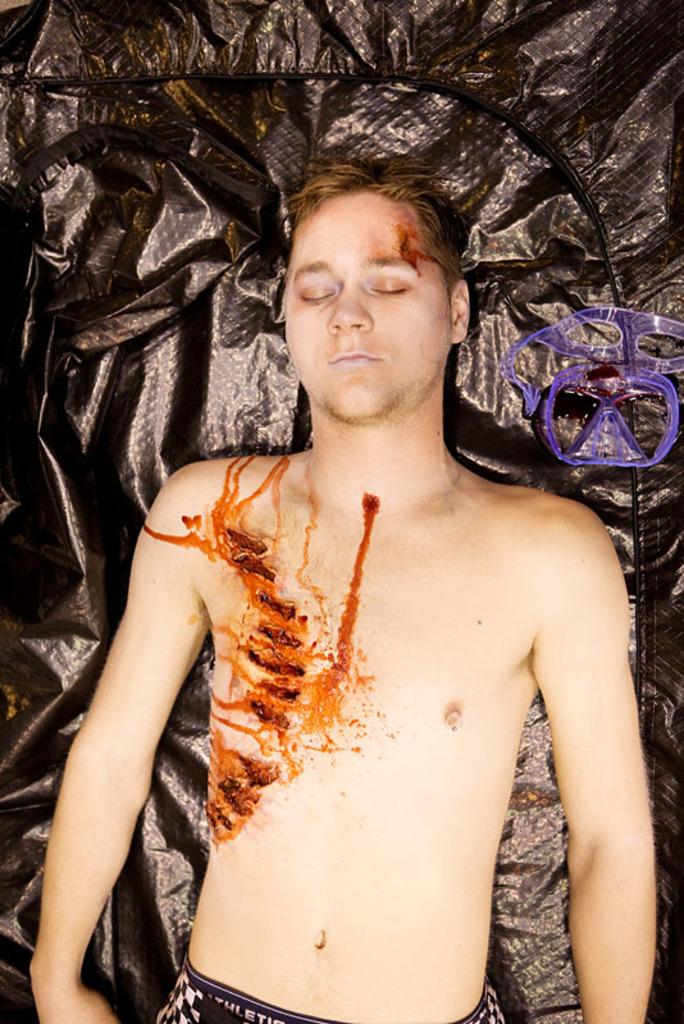What is the main subject of the image? The main subject of the image is a dead body of a boy. What is the dead body lying on? The dead body is lying on a black plastic cover. How many legs does the attention-grabbing mark have in the image? There is no attention-grabbing mark or any legs present in the image. 